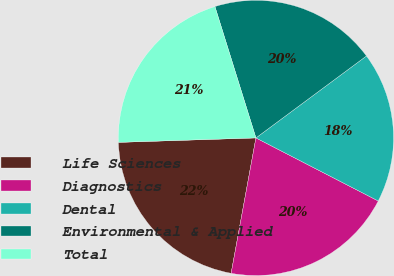<chart> <loc_0><loc_0><loc_500><loc_500><pie_chart><fcel>Life Sciences<fcel>Diagnostics<fcel>Dental<fcel>Environmental & Applied<fcel>Total<nl><fcel>21.6%<fcel>20.31%<fcel>17.73%<fcel>19.66%<fcel>20.7%<nl></chart> 